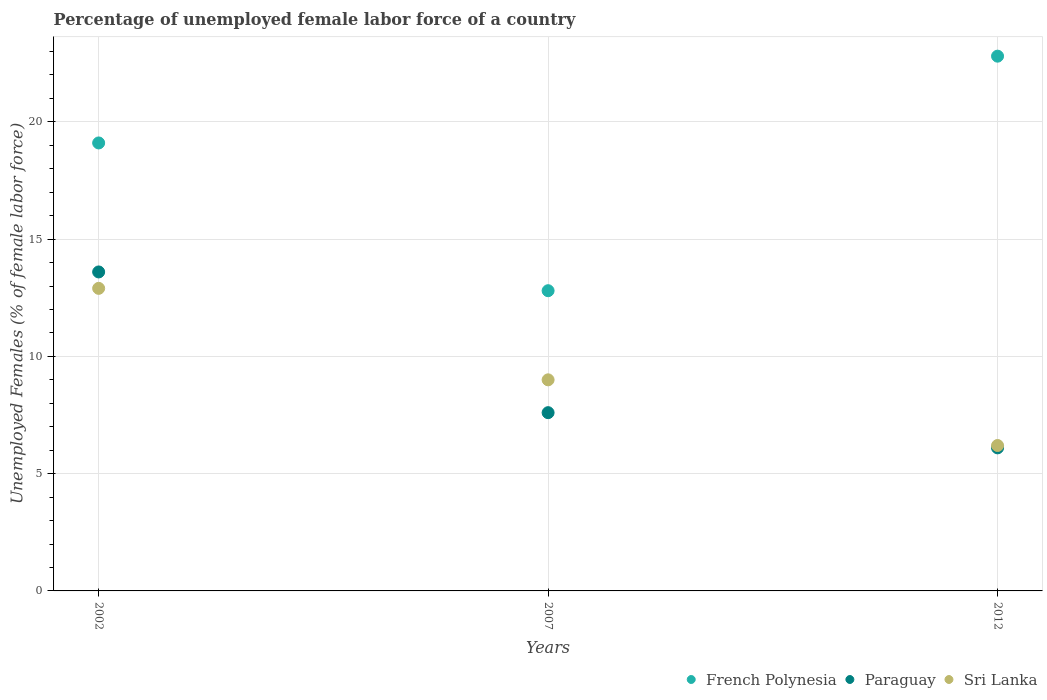What is the percentage of unemployed female labor force in Paraguay in 2002?
Provide a succinct answer. 13.6. Across all years, what is the maximum percentage of unemployed female labor force in French Polynesia?
Give a very brief answer. 22.8. Across all years, what is the minimum percentage of unemployed female labor force in Paraguay?
Ensure brevity in your answer.  6.1. What is the total percentage of unemployed female labor force in French Polynesia in the graph?
Provide a succinct answer. 54.7. What is the difference between the percentage of unemployed female labor force in Paraguay in 2002 and that in 2012?
Your answer should be compact. 7.5. What is the difference between the percentage of unemployed female labor force in Paraguay in 2002 and the percentage of unemployed female labor force in French Polynesia in 2012?
Your answer should be very brief. -9.2. What is the average percentage of unemployed female labor force in Sri Lanka per year?
Your answer should be compact. 9.37. In the year 2012, what is the difference between the percentage of unemployed female labor force in Paraguay and percentage of unemployed female labor force in French Polynesia?
Ensure brevity in your answer.  -16.7. What is the ratio of the percentage of unemployed female labor force in French Polynesia in 2007 to that in 2012?
Give a very brief answer. 0.56. Is the difference between the percentage of unemployed female labor force in Paraguay in 2002 and 2012 greater than the difference between the percentage of unemployed female labor force in French Polynesia in 2002 and 2012?
Your answer should be very brief. Yes. What is the difference between the highest and the second highest percentage of unemployed female labor force in French Polynesia?
Your answer should be compact. 3.7. What is the difference between the highest and the lowest percentage of unemployed female labor force in Paraguay?
Your response must be concise. 7.5. Is the sum of the percentage of unemployed female labor force in Sri Lanka in 2002 and 2007 greater than the maximum percentage of unemployed female labor force in Paraguay across all years?
Make the answer very short. Yes. Does the percentage of unemployed female labor force in Sri Lanka monotonically increase over the years?
Provide a short and direct response. No. Is the percentage of unemployed female labor force in Paraguay strictly less than the percentage of unemployed female labor force in Sri Lanka over the years?
Your answer should be compact. No. How many years are there in the graph?
Your answer should be very brief. 3. What is the difference between two consecutive major ticks on the Y-axis?
Your answer should be compact. 5. Where does the legend appear in the graph?
Your response must be concise. Bottom right. How are the legend labels stacked?
Keep it short and to the point. Horizontal. What is the title of the graph?
Provide a short and direct response. Percentage of unemployed female labor force of a country. Does "Brunei Darussalam" appear as one of the legend labels in the graph?
Ensure brevity in your answer.  No. What is the label or title of the Y-axis?
Ensure brevity in your answer.  Unemployed Females (% of female labor force). What is the Unemployed Females (% of female labor force) in French Polynesia in 2002?
Your answer should be compact. 19.1. What is the Unemployed Females (% of female labor force) of Paraguay in 2002?
Offer a terse response. 13.6. What is the Unemployed Females (% of female labor force) of Sri Lanka in 2002?
Provide a short and direct response. 12.9. What is the Unemployed Females (% of female labor force) of French Polynesia in 2007?
Provide a short and direct response. 12.8. What is the Unemployed Females (% of female labor force) of Paraguay in 2007?
Keep it short and to the point. 7.6. What is the Unemployed Females (% of female labor force) in French Polynesia in 2012?
Your answer should be compact. 22.8. What is the Unemployed Females (% of female labor force) of Paraguay in 2012?
Provide a succinct answer. 6.1. What is the Unemployed Females (% of female labor force) of Sri Lanka in 2012?
Your answer should be compact. 6.2. Across all years, what is the maximum Unemployed Females (% of female labor force) in French Polynesia?
Your answer should be very brief. 22.8. Across all years, what is the maximum Unemployed Females (% of female labor force) in Paraguay?
Provide a succinct answer. 13.6. Across all years, what is the maximum Unemployed Females (% of female labor force) of Sri Lanka?
Offer a terse response. 12.9. Across all years, what is the minimum Unemployed Females (% of female labor force) in French Polynesia?
Keep it short and to the point. 12.8. Across all years, what is the minimum Unemployed Females (% of female labor force) in Paraguay?
Give a very brief answer. 6.1. Across all years, what is the minimum Unemployed Females (% of female labor force) of Sri Lanka?
Offer a terse response. 6.2. What is the total Unemployed Females (% of female labor force) of French Polynesia in the graph?
Your response must be concise. 54.7. What is the total Unemployed Females (% of female labor force) of Paraguay in the graph?
Provide a short and direct response. 27.3. What is the total Unemployed Females (% of female labor force) in Sri Lanka in the graph?
Offer a terse response. 28.1. What is the difference between the Unemployed Females (% of female labor force) in Paraguay in 2002 and that in 2007?
Give a very brief answer. 6. What is the difference between the Unemployed Females (% of female labor force) of French Polynesia in 2002 and the Unemployed Females (% of female labor force) of Paraguay in 2007?
Provide a succinct answer. 11.5. What is the difference between the Unemployed Females (% of female labor force) in French Polynesia in 2002 and the Unemployed Females (% of female labor force) in Sri Lanka in 2007?
Provide a short and direct response. 10.1. What is the difference between the Unemployed Females (% of female labor force) in French Polynesia in 2002 and the Unemployed Females (% of female labor force) in Sri Lanka in 2012?
Provide a short and direct response. 12.9. What is the difference between the Unemployed Females (% of female labor force) in Paraguay in 2002 and the Unemployed Females (% of female labor force) in Sri Lanka in 2012?
Keep it short and to the point. 7.4. What is the difference between the Unemployed Females (% of female labor force) in Paraguay in 2007 and the Unemployed Females (% of female labor force) in Sri Lanka in 2012?
Provide a short and direct response. 1.4. What is the average Unemployed Females (% of female labor force) in French Polynesia per year?
Your answer should be compact. 18.23. What is the average Unemployed Females (% of female labor force) in Sri Lanka per year?
Offer a terse response. 9.37. In the year 2002, what is the difference between the Unemployed Females (% of female labor force) in French Polynesia and Unemployed Females (% of female labor force) in Sri Lanka?
Make the answer very short. 6.2. In the year 2007, what is the difference between the Unemployed Females (% of female labor force) in French Polynesia and Unemployed Females (% of female labor force) in Sri Lanka?
Provide a succinct answer. 3.8. In the year 2007, what is the difference between the Unemployed Females (% of female labor force) in Paraguay and Unemployed Females (% of female labor force) in Sri Lanka?
Your answer should be compact. -1.4. What is the ratio of the Unemployed Females (% of female labor force) in French Polynesia in 2002 to that in 2007?
Provide a succinct answer. 1.49. What is the ratio of the Unemployed Females (% of female labor force) in Paraguay in 2002 to that in 2007?
Provide a succinct answer. 1.79. What is the ratio of the Unemployed Females (% of female labor force) in Sri Lanka in 2002 to that in 2007?
Provide a succinct answer. 1.43. What is the ratio of the Unemployed Females (% of female labor force) of French Polynesia in 2002 to that in 2012?
Your answer should be very brief. 0.84. What is the ratio of the Unemployed Females (% of female labor force) of Paraguay in 2002 to that in 2012?
Your answer should be very brief. 2.23. What is the ratio of the Unemployed Females (% of female labor force) in Sri Lanka in 2002 to that in 2012?
Keep it short and to the point. 2.08. What is the ratio of the Unemployed Females (% of female labor force) in French Polynesia in 2007 to that in 2012?
Offer a terse response. 0.56. What is the ratio of the Unemployed Females (% of female labor force) in Paraguay in 2007 to that in 2012?
Provide a succinct answer. 1.25. What is the ratio of the Unemployed Females (% of female labor force) of Sri Lanka in 2007 to that in 2012?
Provide a short and direct response. 1.45. What is the difference between the highest and the lowest Unemployed Females (% of female labor force) of French Polynesia?
Ensure brevity in your answer.  10. What is the difference between the highest and the lowest Unemployed Females (% of female labor force) of Sri Lanka?
Ensure brevity in your answer.  6.7. 